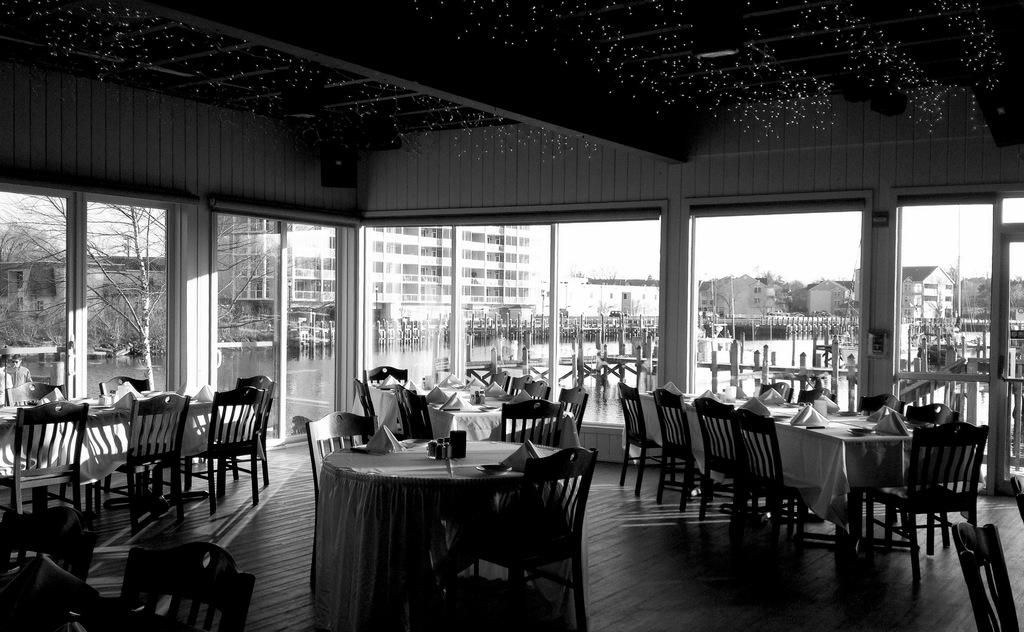What type of structures are visible in the image? There are buildings in the image. What type of furniture is present in the image? There are chairs and tables in the image. What can be seen in the background of the image? There are trees in the background of the image. What is on the tables in the image? White color clothes are present on the tables. What is visible at the top of the image? The sky is visible at the top of the image. Can you tell me how many wrens are sitting on the door in the image? There is no door or wrens present in the image. What type of pail is used to water the trees in the image? There is no pail or indication of watering the trees in the image. 